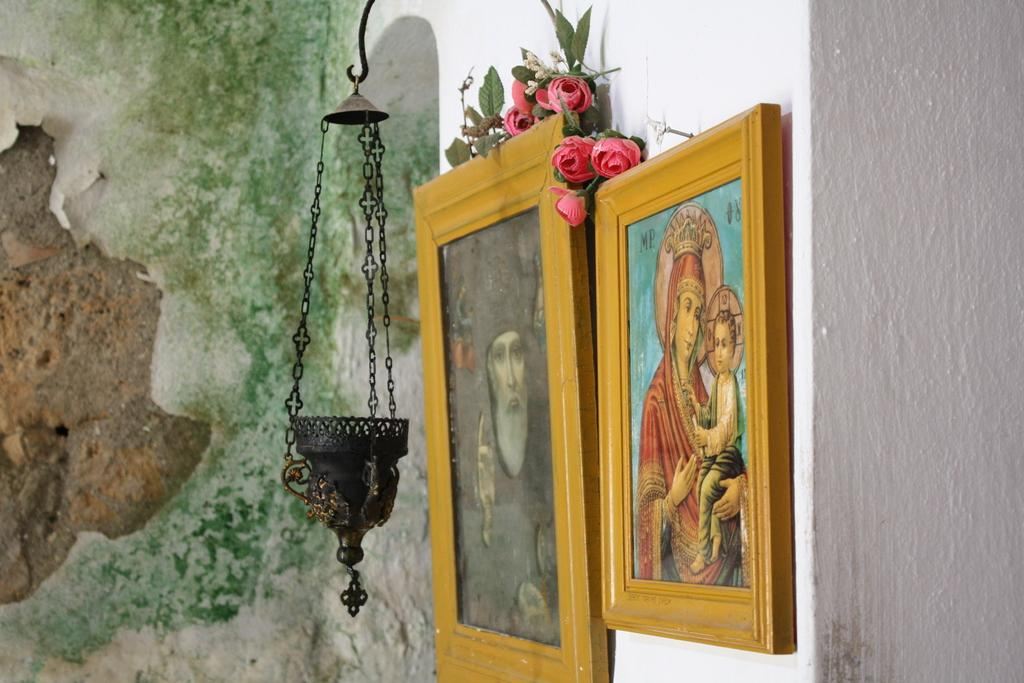What is hanging on the wall in the image? There are photo frames on the wall in the image. What can be seen in the photo frames? The photo frames contain images of leaves and flowers. Can you describe the metal object hanging in the image? Unfortunately, the facts provided do not mention a metal object hanging in the image. How many silk spiders are weaving webs on the metal object in the image? There is no metal object or silk spiders present in the image. 